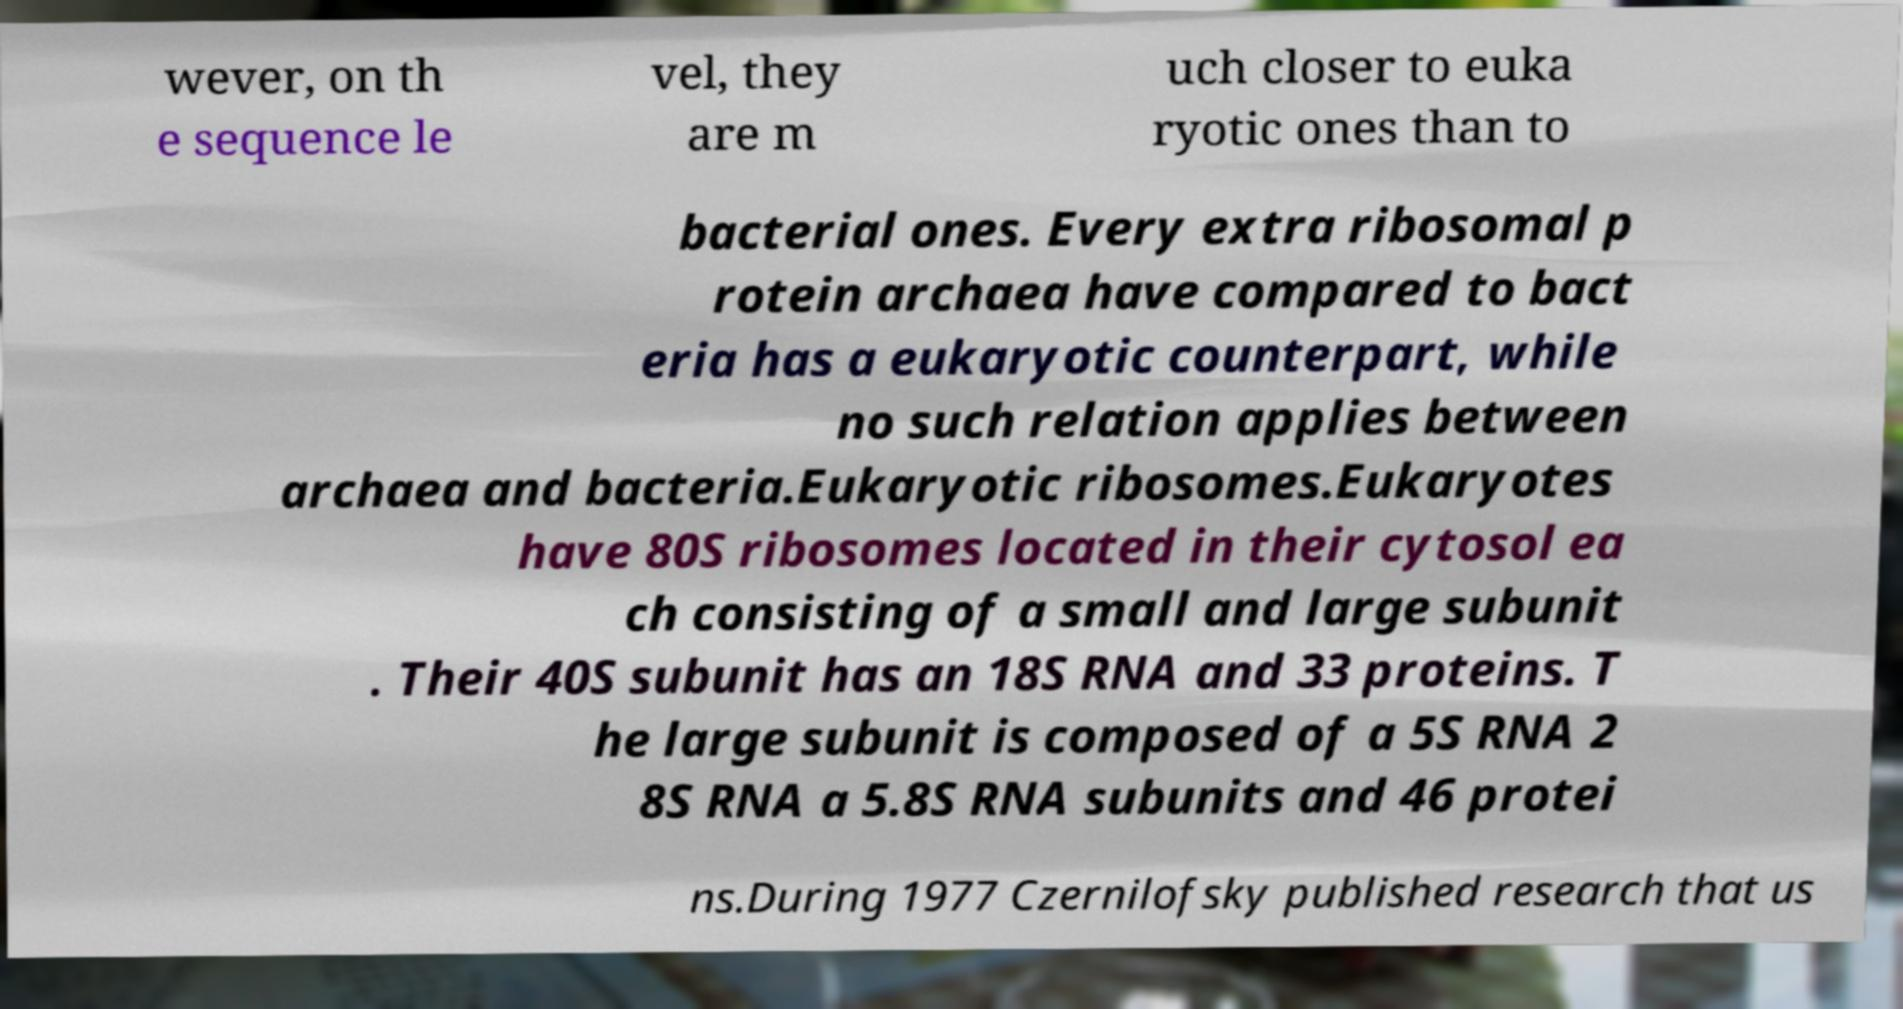Can you accurately transcribe the text from the provided image for me? wever, on th e sequence le vel, they are m uch closer to euka ryotic ones than to bacterial ones. Every extra ribosomal p rotein archaea have compared to bact eria has a eukaryotic counterpart, while no such relation applies between archaea and bacteria.Eukaryotic ribosomes.Eukaryotes have 80S ribosomes located in their cytosol ea ch consisting of a small and large subunit . Their 40S subunit has an 18S RNA and 33 proteins. T he large subunit is composed of a 5S RNA 2 8S RNA a 5.8S RNA subunits and 46 protei ns.During 1977 Czernilofsky published research that us 